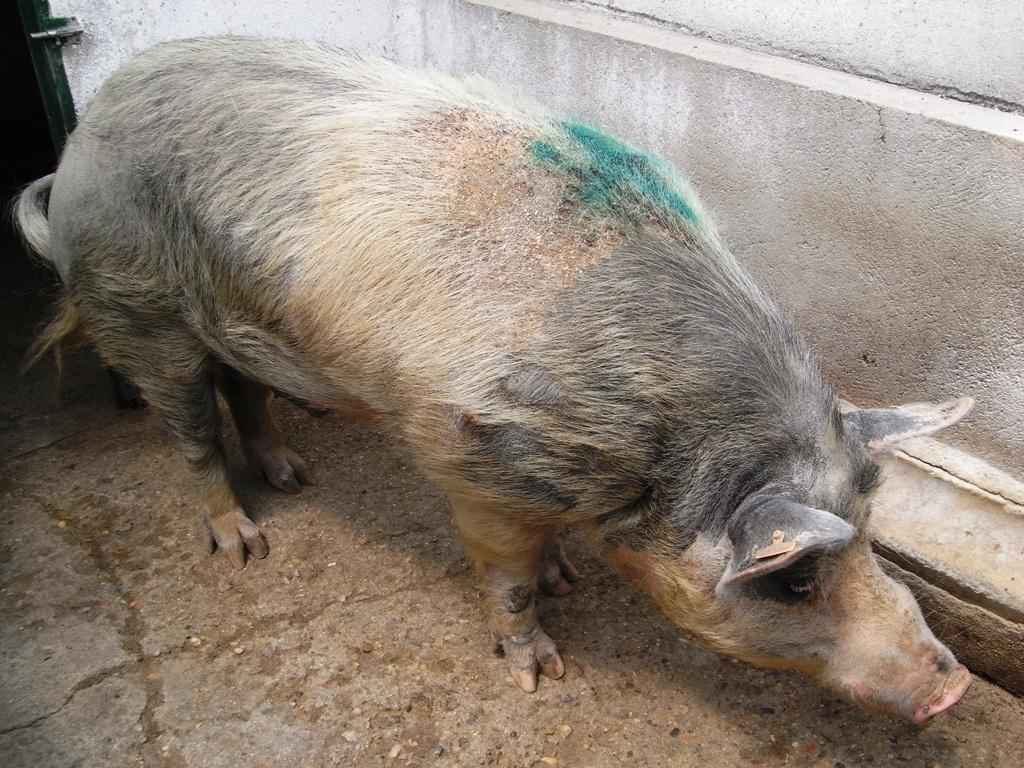What animal is present in the image? There is a pig in the image. What colors can be seen on the pig? The pig has brown and black colors. What is visible to the right side of the image? There is a wall visible to the right of the image. What type of beef can be seen in the image? There is no beef present in the image; it features a pig. What test is being conducted on the pig in the image? There is no test being conducted on the pig in the image; it is simply depicted as it is. 